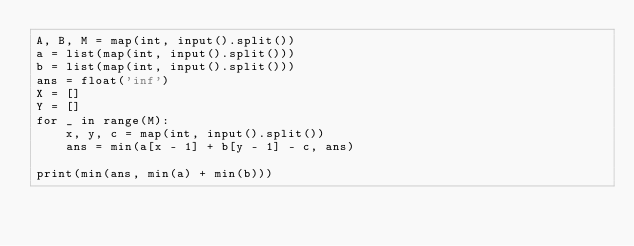Convert code to text. <code><loc_0><loc_0><loc_500><loc_500><_Python_>A, B, M = map(int, input().split())
a = list(map(int, input().split()))
b = list(map(int, input().split()))
ans = float('inf')
X = []
Y = []
for _ in range(M):
    x, y, c = map(int, input().split())
    ans = min(a[x - 1] + b[y - 1] - c, ans)

print(min(ans, min(a) + min(b)))
</code> 